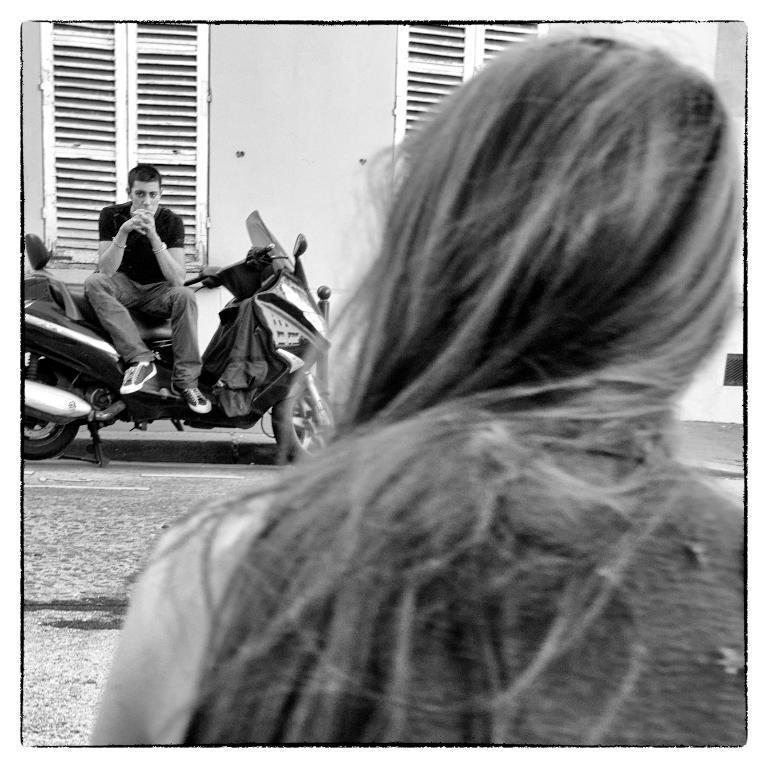Could you give a brief overview of what you see in this image? It is the black and white image in which there is a girl with the long hair in the middle. In front of her there is a man sitting on the bike. Beside him there are windows. 